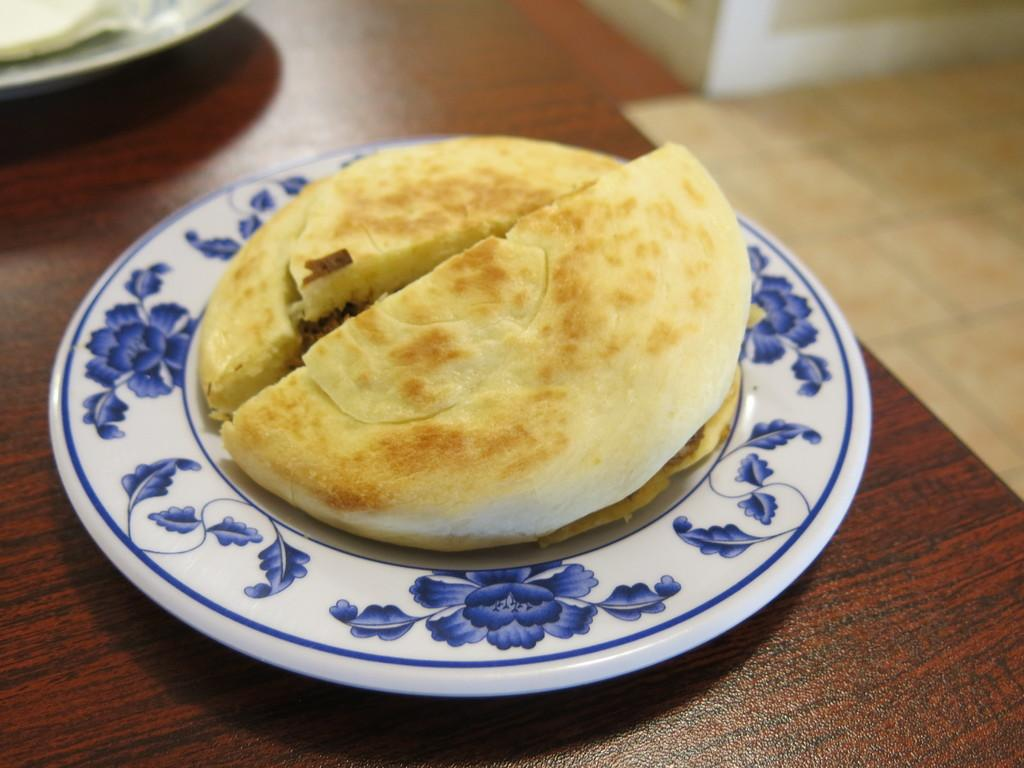What is the main subject of the image? There is a food item on a plate in the image. Where is the plate with the food item located? The plate is placed on a table. Can you describe any other plates visible in the image? There is a plate visible in the background of the image. What day of the week is it according to the calendar in the image? There is no calendar present in the image, so it is not possible to determine the day of the week. 